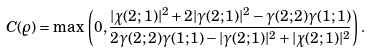<formula> <loc_0><loc_0><loc_500><loc_500>C ( \varrho ) = \max \, \left ( 0 , \frac { | \chi ( 2 ; 1 ) | ^ { 2 } + 2 | \gamma ( 2 ; 1 ) | ^ { 2 } - \gamma ( 2 ; 2 ) \gamma ( 1 ; 1 ) } { 2 \gamma ( 2 ; 2 ) \gamma ( 1 ; 1 ) - | \gamma ( 2 ; 1 ) | ^ { 2 } + | \chi ( 2 ; 1 ) | ^ { 2 } } \right ) .</formula> 